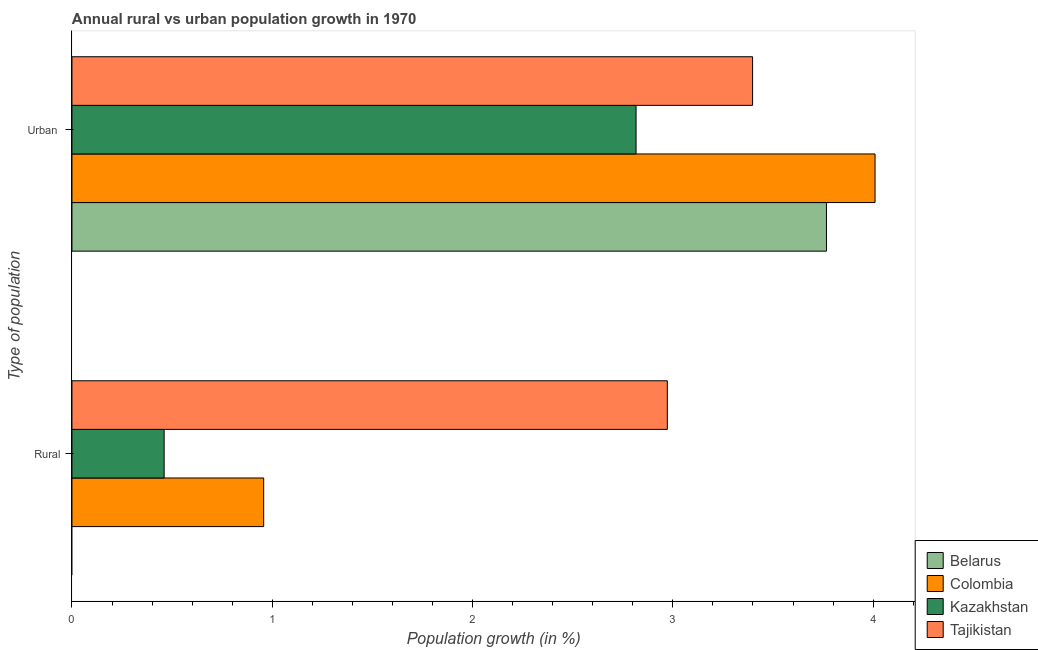How many bars are there on the 1st tick from the top?
Offer a very short reply. 4. How many bars are there on the 2nd tick from the bottom?
Keep it short and to the point. 4. What is the label of the 1st group of bars from the top?
Offer a very short reply. Urban . What is the urban population growth in Colombia?
Your response must be concise. 4.01. Across all countries, what is the maximum urban population growth?
Offer a terse response. 4.01. Across all countries, what is the minimum urban population growth?
Keep it short and to the point. 2.82. What is the total rural population growth in the graph?
Provide a succinct answer. 4.39. What is the difference between the urban population growth in Tajikistan and that in Belarus?
Make the answer very short. -0.37. What is the difference between the rural population growth in Colombia and the urban population growth in Belarus?
Keep it short and to the point. -2.81. What is the average urban population growth per country?
Offer a terse response. 3.5. What is the difference between the rural population growth and urban population growth in Colombia?
Make the answer very short. -3.05. What is the ratio of the urban population growth in Belarus to that in Colombia?
Your response must be concise. 0.94. In how many countries, is the urban population growth greater than the average urban population growth taken over all countries?
Offer a very short reply. 2. Are all the bars in the graph horizontal?
Keep it short and to the point. Yes. How many countries are there in the graph?
Offer a terse response. 4. What is the difference between two consecutive major ticks on the X-axis?
Your answer should be very brief. 1. Does the graph contain any zero values?
Your answer should be very brief. Yes. Does the graph contain grids?
Offer a very short reply. No. Where does the legend appear in the graph?
Ensure brevity in your answer.  Bottom right. How are the legend labels stacked?
Keep it short and to the point. Vertical. What is the title of the graph?
Offer a terse response. Annual rural vs urban population growth in 1970. What is the label or title of the X-axis?
Ensure brevity in your answer.  Population growth (in %). What is the label or title of the Y-axis?
Give a very brief answer. Type of population. What is the Population growth (in %) in Colombia in Rural?
Your answer should be very brief. 0.96. What is the Population growth (in %) in Kazakhstan in Rural?
Provide a short and direct response. 0.46. What is the Population growth (in %) of Tajikistan in Rural?
Offer a terse response. 2.97. What is the Population growth (in %) in Belarus in Urban ?
Give a very brief answer. 3.77. What is the Population growth (in %) of Colombia in Urban ?
Give a very brief answer. 4.01. What is the Population growth (in %) of Kazakhstan in Urban ?
Provide a short and direct response. 2.82. What is the Population growth (in %) in Tajikistan in Urban ?
Make the answer very short. 3.4. Across all Type of population, what is the maximum Population growth (in %) of Belarus?
Provide a short and direct response. 3.77. Across all Type of population, what is the maximum Population growth (in %) of Colombia?
Your answer should be very brief. 4.01. Across all Type of population, what is the maximum Population growth (in %) of Kazakhstan?
Your answer should be very brief. 2.82. Across all Type of population, what is the maximum Population growth (in %) of Tajikistan?
Offer a very short reply. 3.4. Across all Type of population, what is the minimum Population growth (in %) of Colombia?
Keep it short and to the point. 0.96. Across all Type of population, what is the minimum Population growth (in %) in Kazakhstan?
Your answer should be compact. 0.46. Across all Type of population, what is the minimum Population growth (in %) in Tajikistan?
Ensure brevity in your answer.  2.97. What is the total Population growth (in %) in Belarus in the graph?
Your response must be concise. 3.77. What is the total Population growth (in %) of Colombia in the graph?
Give a very brief answer. 4.97. What is the total Population growth (in %) of Kazakhstan in the graph?
Keep it short and to the point. 3.28. What is the total Population growth (in %) of Tajikistan in the graph?
Your response must be concise. 6.37. What is the difference between the Population growth (in %) in Colombia in Rural and that in Urban ?
Your answer should be compact. -3.05. What is the difference between the Population growth (in %) in Kazakhstan in Rural and that in Urban ?
Provide a short and direct response. -2.36. What is the difference between the Population growth (in %) in Tajikistan in Rural and that in Urban ?
Keep it short and to the point. -0.43. What is the difference between the Population growth (in %) of Colombia in Rural and the Population growth (in %) of Kazakhstan in Urban ?
Offer a terse response. -1.86. What is the difference between the Population growth (in %) of Colombia in Rural and the Population growth (in %) of Tajikistan in Urban ?
Make the answer very short. -2.44. What is the difference between the Population growth (in %) in Kazakhstan in Rural and the Population growth (in %) in Tajikistan in Urban ?
Ensure brevity in your answer.  -2.94. What is the average Population growth (in %) of Belarus per Type of population?
Offer a terse response. 1.88. What is the average Population growth (in %) of Colombia per Type of population?
Offer a very short reply. 2.48. What is the average Population growth (in %) of Kazakhstan per Type of population?
Make the answer very short. 1.64. What is the average Population growth (in %) in Tajikistan per Type of population?
Offer a terse response. 3.19. What is the difference between the Population growth (in %) in Colombia and Population growth (in %) in Kazakhstan in Rural?
Your response must be concise. 0.5. What is the difference between the Population growth (in %) in Colombia and Population growth (in %) in Tajikistan in Rural?
Keep it short and to the point. -2.02. What is the difference between the Population growth (in %) in Kazakhstan and Population growth (in %) in Tajikistan in Rural?
Keep it short and to the point. -2.51. What is the difference between the Population growth (in %) in Belarus and Population growth (in %) in Colombia in Urban ?
Your response must be concise. -0.24. What is the difference between the Population growth (in %) of Belarus and Population growth (in %) of Kazakhstan in Urban ?
Keep it short and to the point. 0.95. What is the difference between the Population growth (in %) in Belarus and Population growth (in %) in Tajikistan in Urban ?
Offer a very short reply. 0.37. What is the difference between the Population growth (in %) in Colombia and Population growth (in %) in Kazakhstan in Urban ?
Your response must be concise. 1.19. What is the difference between the Population growth (in %) of Colombia and Population growth (in %) of Tajikistan in Urban ?
Give a very brief answer. 0.61. What is the difference between the Population growth (in %) of Kazakhstan and Population growth (in %) of Tajikistan in Urban ?
Provide a succinct answer. -0.58. What is the ratio of the Population growth (in %) in Colombia in Rural to that in Urban ?
Your response must be concise. 0.24. What is the ratio of the Population growth (in %) of Kazakhstan in Rural to that in Urban ?
Keep it short and to the point. 0.16. What is the ratio of the Population growth (in %) in Tajikistan in Rural to that in Urban ?
Make the answer very short. 0.87. What is the difference between the highest and the second highest Population growth (in %) in Colombia?
Ensure brevity in your answer.  3.05. What is the difference between the highest and the second highest Population growth (in %) of Kazakhstan?
Provide a succinct answer. 2.36. What is the difference between the highest and the second highest Population growth (in %) of Tajikistan?
Your answer should be very brief. 0.43. What is the difference between the highest and the lowest Population growth (in %) of Belarus?
Your response must be concise. 3.77. What is the difference between the highest and the lowest Population growth (in %) in Colombia?
Give a very brief answer. 3.05. What is the difference between the highest and the lowest Population growth (in %) of Kazakhstan?
Keep it short and to the point. 2.36. What is the difference between the highest and the lowest Population growth (in %) in Tajikistan?
Keep it short and to the point. 0.43. 